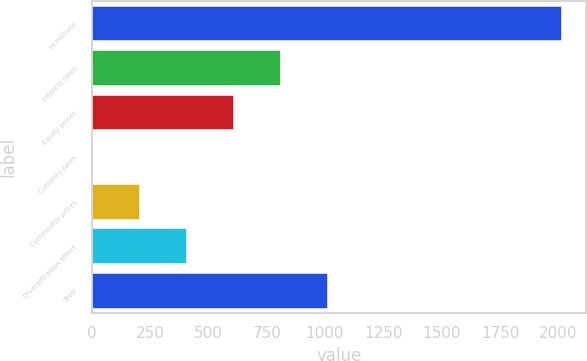Convert chart. <chart><loc_0><loc_0><loc_500><loc_500><bar_chart><fcel>in millions<fcel>Interest rates<fcel>Equity prices<fcel>Currency rates<fcel>Commodity prices<fcel>Diversification effect<fcel>Total<nl><fcel>2017<fcel>811<fcel>610<fcel>7<fcel>208<fcel>409<fcel>1012<nl></chart> 